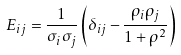<formula> <loc_0><loc_0><loc_500><loc_500>E _ { i j } = \frac { 1 } { \sigma _ { i } \sigma _ { j } } \left ( \delta _ { i j } - \frac { \rho _ { i } \rho _ { j } } { 1 + \rho ^ { 2 } } \right )</formula> 